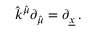<formula> <loc_0><loc_0><loc_500><loc_500>\hat { k } ^ { \hat { \mu } } \partial _ { \hat { \mu } } = \partial _ { \underline { x } } \, .</formula> 